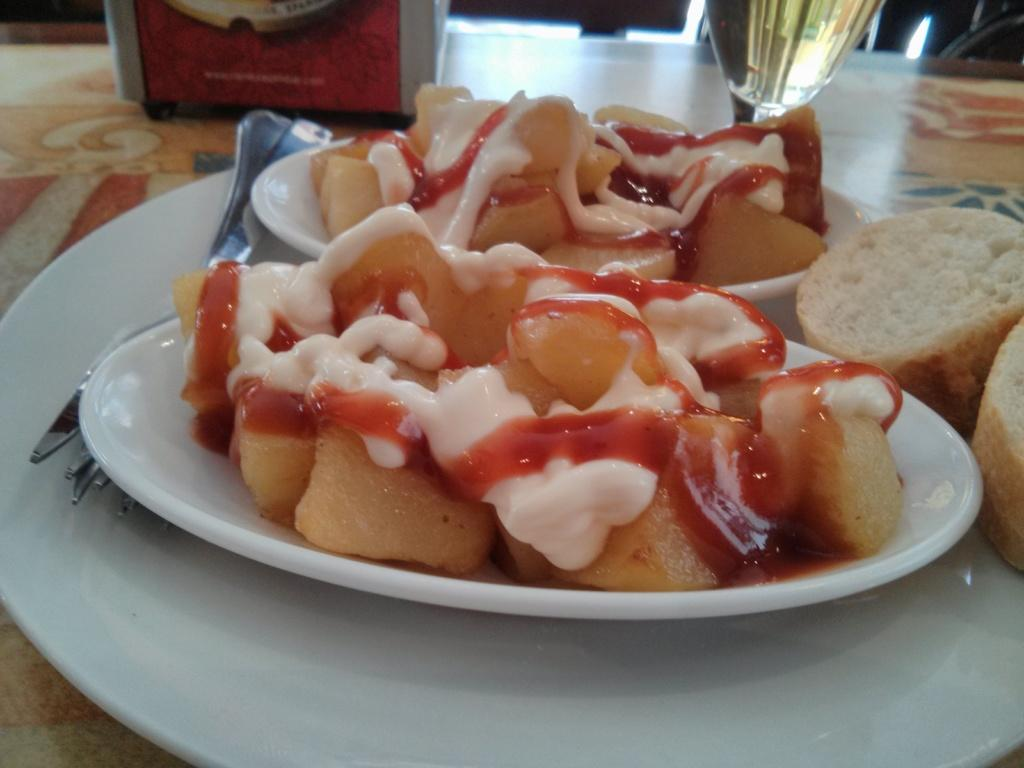What is the main object in the center of the image? There is a table in the center of the image. What can be found on the table? There is a glass, forks, plates, breads, a bowl, and food placed on the table. What type of utensils are on the table? There are forks on the table. What is contained in the bowl on the table? The facts do not specify what is in the bowl, so we cannot answer that question definitively. How many deer are visible in the image? There are no deer present in the image. What grade is the food on the table? The facts do not mention any grades associated with the food, so we cannot answer that question definitively. 